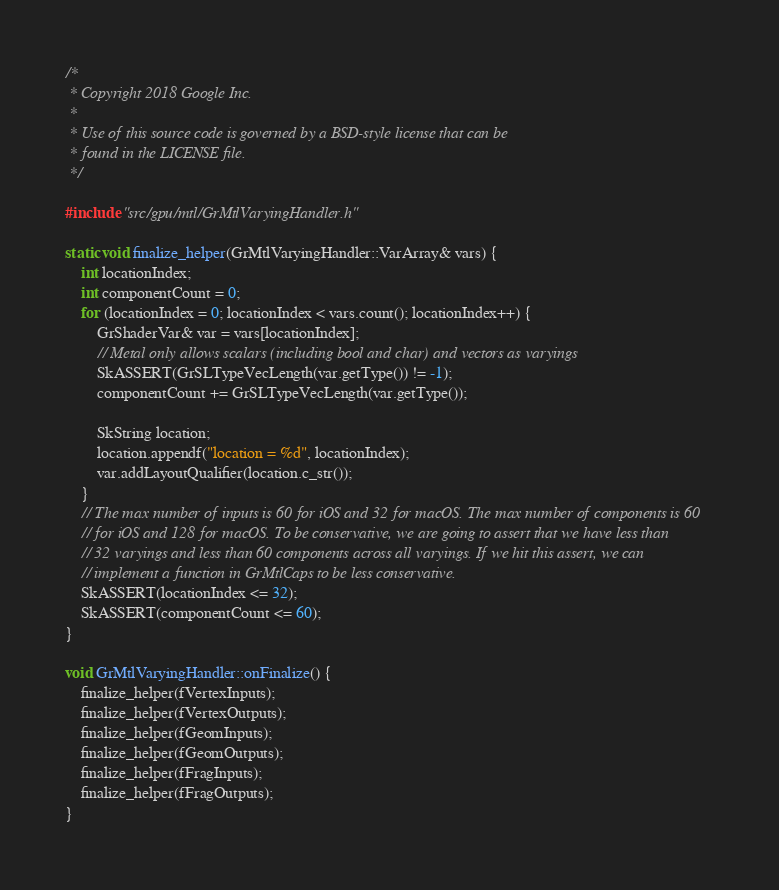<code> <loc_0><loc_0><loc_500><loc_500><_ObjectiveC_>/*
 * Copyright 2018 Google Inc.
 *
 * Use of this source code is governed by a BSD-style license that can be
 * found in the LICENSE file.
 */

#include "src/gpu/mtl/GrMtlVaryingHandler.h"

static void finalize_helper(GrMtlVaryingHandler::VarArray& vars) {
    int locationIndex;
    int componentCount = 0;
    for (locationIndex = 0; locationIndex < vars.count(); locationIndex++) {
        GrShaderVar& var = vars[locationIndex];
        // Metal only allows scalars (including bool and char) and vectors as varyings
        SkASSERT(GrSLTypeVecLength(var.getType()) != -1);
        componentCount += GrSLTypeVecLength(var.getType());

        SkString location;
        location.appendf("location = %d", locationIndex);
        var.addLayoutQualifier(location.c_str());
    }
    // The max number of inputs is 60 for iOS and 32 for macOS. The max number of components is 60
    // for iOS and 128 for macOS. To be conservative, we are going to assert that we have less than
    // 32 varyings and less than 60 components across all varyings. If we hit this assert, we can
    // implement a function in GrMtlCaps to be less conservative.
    SkASSERT(locationIndex <= 32);
    SkASSERT(componentCount <= 60);
}

void GrMtlVaryingHandler::onFinalize() {
    finalize_helper(fVertexInputs);
    finalize_helper(fVertexOutputs);
    finalize_helper(fGeomInputs);
    finalize_helper(fGeomOutputs);
    finalize_helper(fFragInputs);
    finalize_helper(fFragOutputs);
}
</code> 